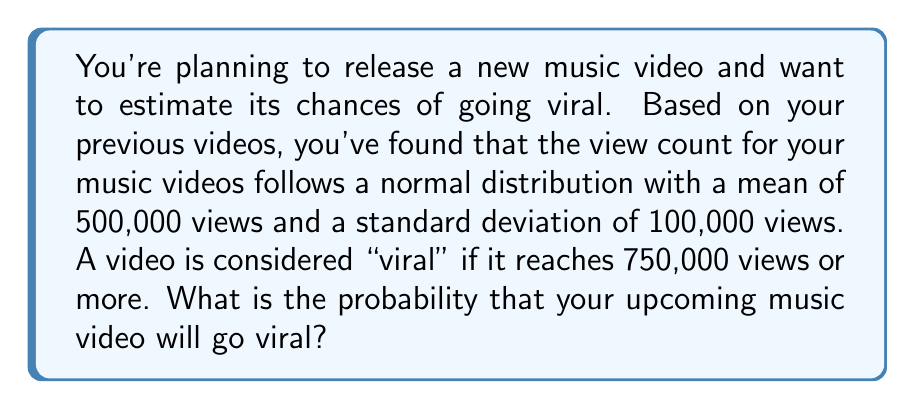Show me your answer to this math problem. To solve this problem, we need to use the properties of the normal distribution and calculate the z-score for the viral threshold.

1. Given information:
   - Mean (μ) = 500,000 views
   - Standard deviation (σ) = 100,000 views
   - Viral threshold = 750,000 views

2. Calculate the z-score for the viral threshold:
   $$z = \frac{x - \mu}{\sigma} = \frac{750,000 - 500,000}{100,000} = \frac{250,000}{100,000} = 2.5$$

3. The probability of going viral is the area to the right of z = 2.5 on the standard normal distribution.

4. Using a standard normal distribution table or calculator, we find:
   P(Z > 2.5) = 1 - P(Z ≤ 2.5) = 1 - 0.9938 = 0.0062

5. Convert the probability to a percentage:
   0.0062 * 100 = 0.62%

Therefore, the probability that your upcoming music video will go viral (reach 750,000 views or more) is approximately 0.62% or 0.0062.
Answer: The probability that the upcoming music video will go viral is approximately 0.62% or 0.0062. 